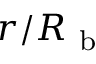<formula> <loc_0><loc_0><loc_500><loc_500>r / R _ { b }</formula> 